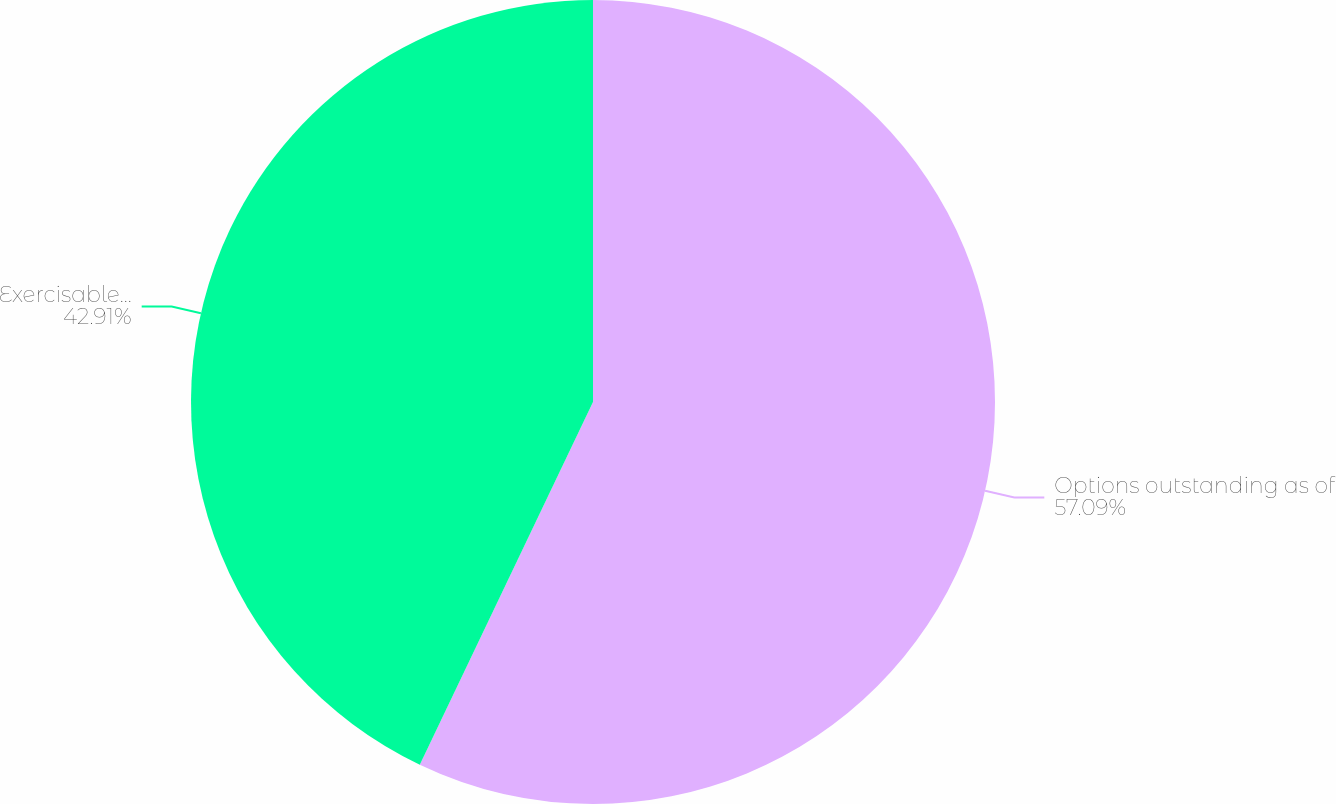Convert chart. <chart><loc_0><loc_0><loc_500><loc_500><pie_chart><fcel>Options outstanding as of<fcel>Exercisable as of December 31<nl><fcel>57.09%<fcel>42.91%<nl></chart> 